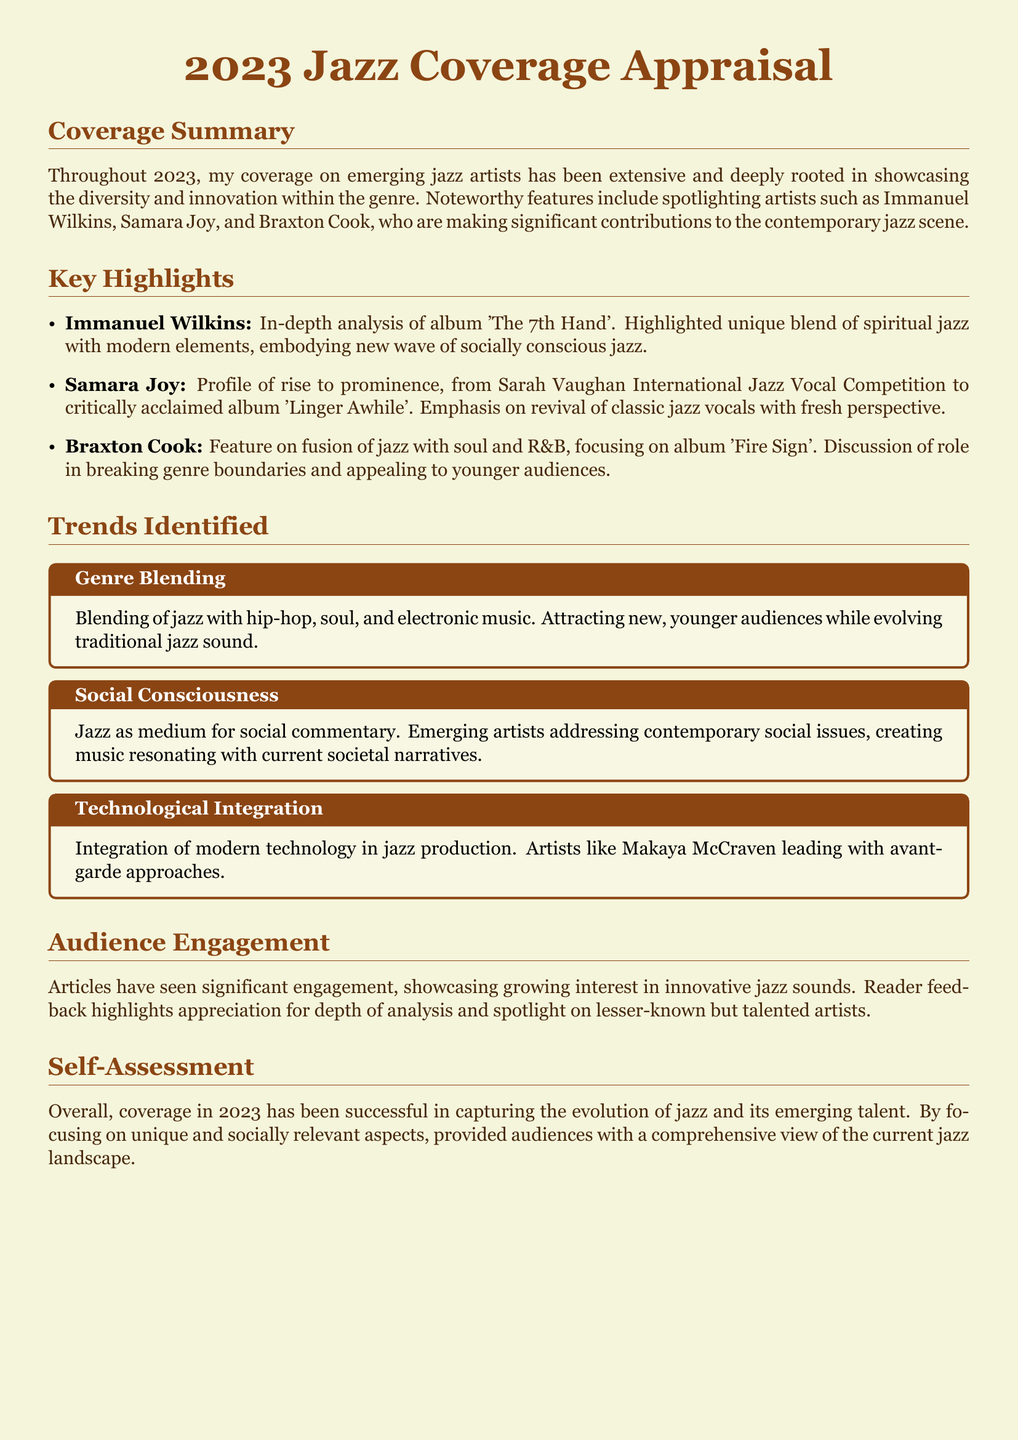What is the title of the appraisal document? The title of the appraisal document is prominently displayed at the beginning.
Answer: 2023 Jazz Coverage Appraisal Who is the artist featured for the album 'The 7th Hand'? The document highlights specific artists and their works.
Answer: Immanuel Wilkins What genre blending trend is mentioned? The document identifies key trends, including genre blending.
Answer: Hip-hop, soul, and electronic music What is noted about audience engagement? The document discusses the impact of the articles on engagement with readers.
Answer: Significant engagement Which artist's album focuses on the revival of classic jazz vocals? The document emphasizes the rise of specific artists and their contributions.
Answer: Samara Joy How is technology integrated into jazz production according to the document? The document outlines trends in contemporary jazz, including technology use.
Answer: Modern technology What social theme do emerging artists address in their music? The coverage highlights the themes addressed by the artists in their work.
Answer: Social commentary Which artist fuses jazz with soul and R&B? The document specifies the works of artists blending different genres.
Answer: Braxton Cook 